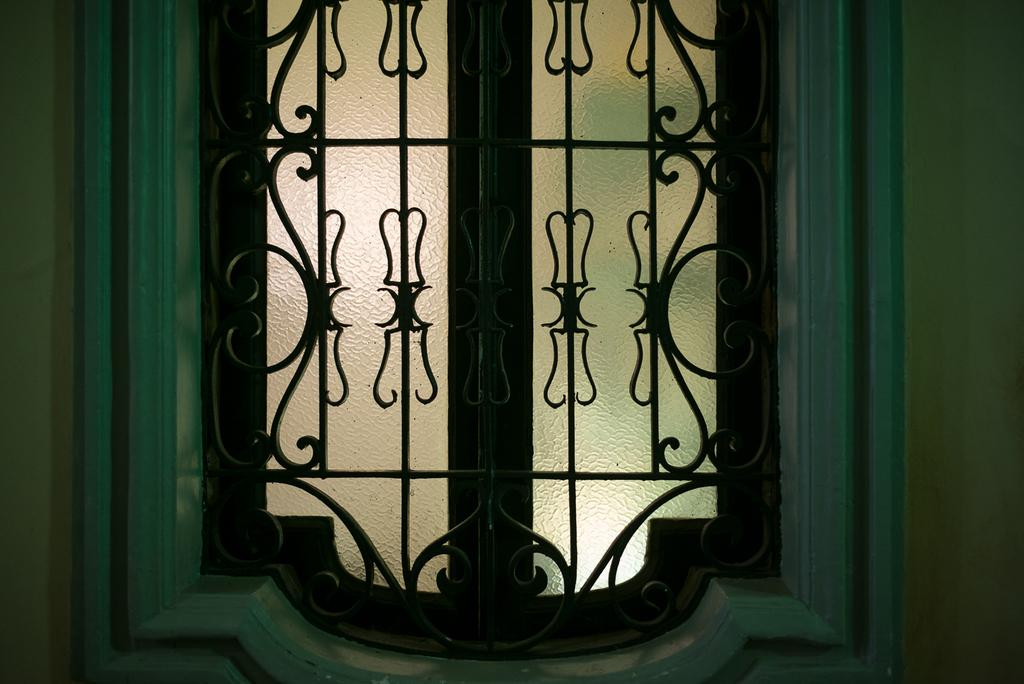What is present in the wall in the image? There is a window in the wall in the image. What feature is associated with the window? There is a grill associated with the window. What type of pickle can be seen growing through the hole in the wall? There is no pickle or hole present in the image. 